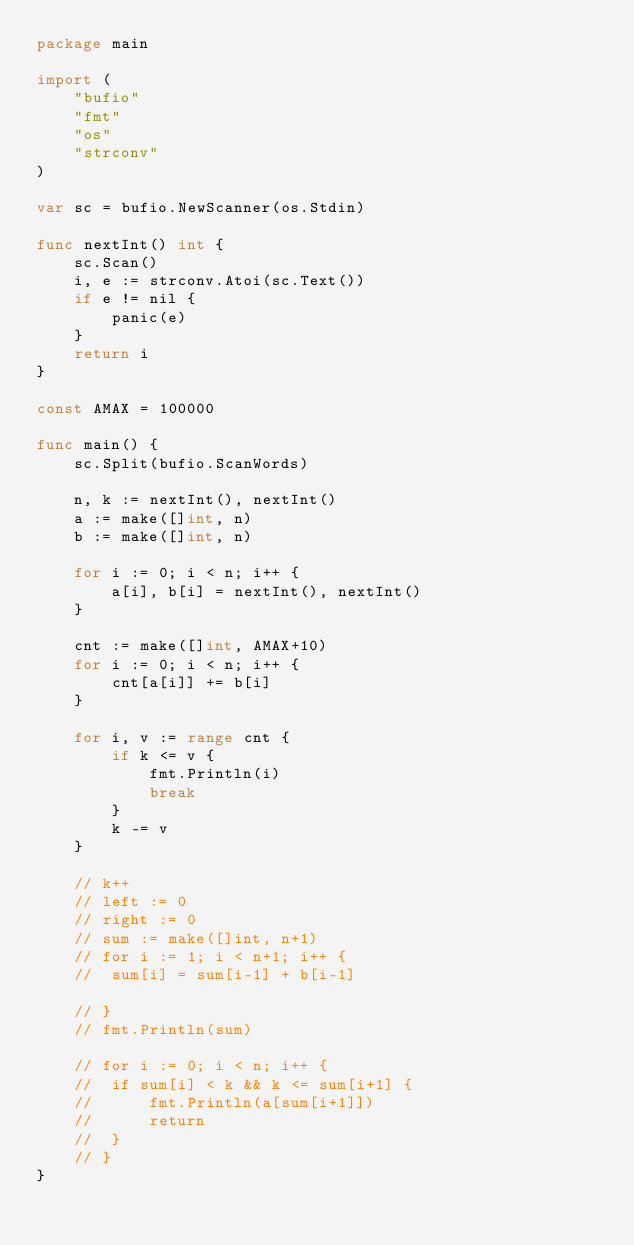Convert code to text. <code><loc_0><loc_0><loc_500><loc_500><_Go_>package main

import (
	"bufio"
	"fmt"
	"os"
	"strconv"
)

var sc = bufio.NewScanner(os.Stdin)

func nextInt() int {
	sc.Scan()
	i, e := strconv.Atoi(sc.Text())
	if e != nil {
		panic(e)
	}
	return i
}

const AMAX = 100000

func main() {
	sc.Split(bufio.ScanWords)

	n, k := nextInt(), nextInt()
	a := make([]int, n)
	b := make([]int, n)

	for i := 0; i < n; i++ {
		a[i], b[i] = nextInt(), nextInt()
	}

	cnt := make([]int, AMAX+10)
	for i := 0; i < n; i++ {
		cnt[a[i]] += b[i]
	}

	for i, v := range cnt {
		if k <= v {
			fmt.Println(i)
			break
		}
		k -= v
	}

	// k++
	// left := 0
	// right := 0
	// sum := make([]int, n+1)
	// for i := 1; i < n+1; i++ {
	// 	sum[i] = sum[i-1] + b[i-1]

	// }
	// fmt.Println(sum)

	// for i := 0; i < n; i++ {
	// 	if sum[i] < k && k <= sum[i+1] {
	// 		fmt.Println(a[sum[i+1]])
	// 		return
	// 	}
	// }
}
</code> 